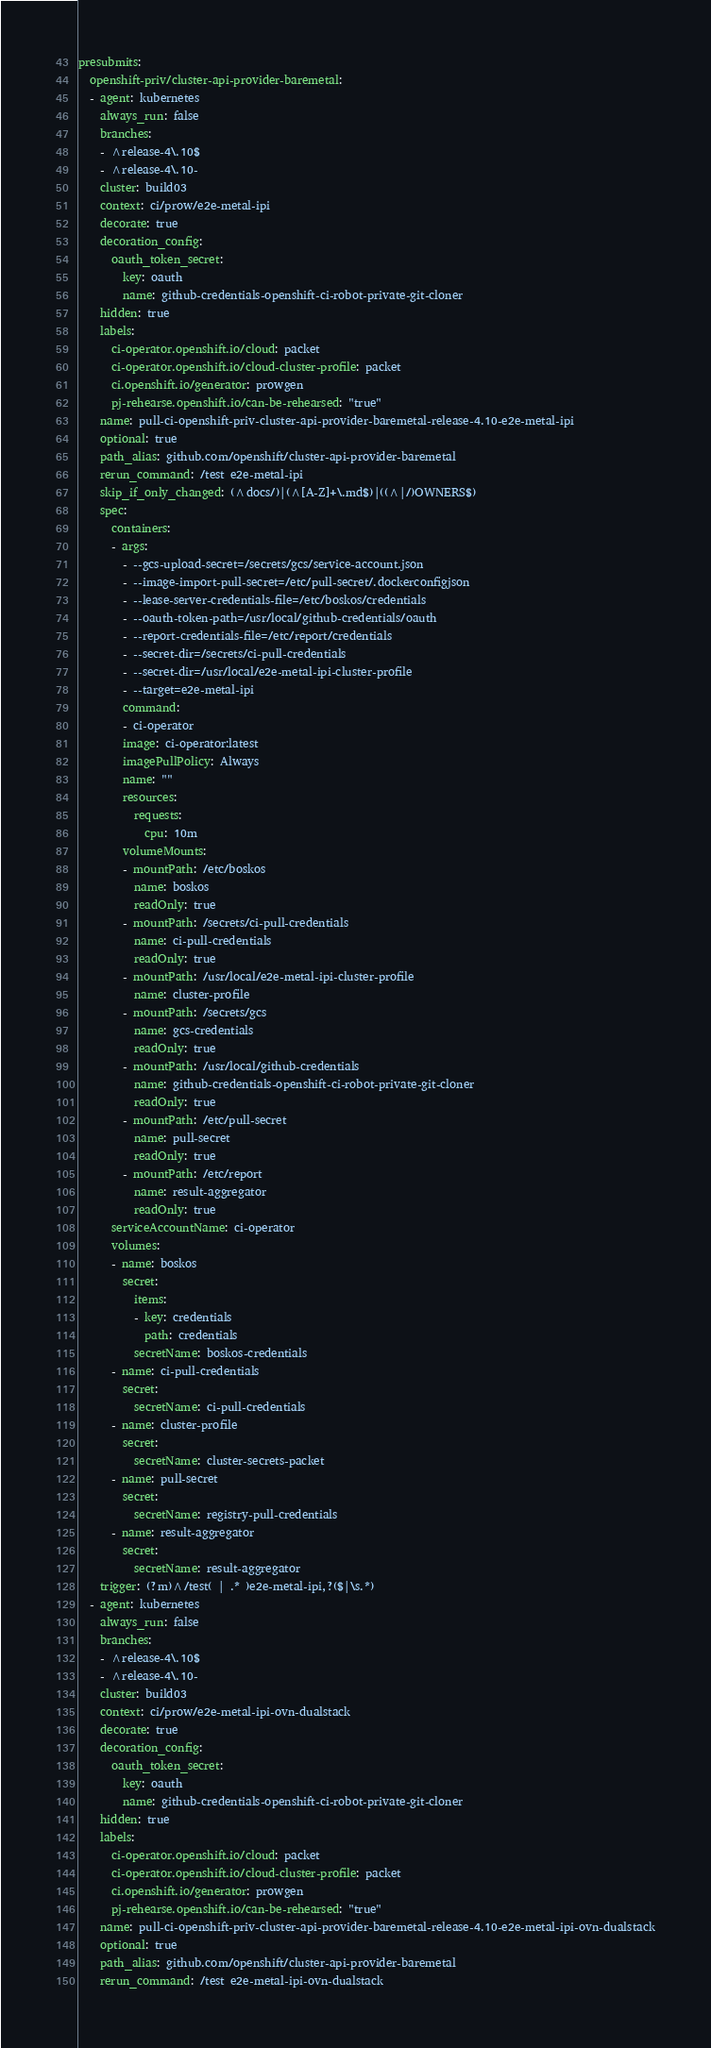<code> <loc_0><loc_0><loc_500><loc_500><_YAML_>presubmits:
  openshift-priv/cluster-api-provider-baremetal:
  - agent: kubernetes
    always_run: false
    branches:
    - ^release-4\.10$
    - ^release-4\.10-
    cluster: build03
    context: ci/prow/e2e-metal-ipi
    decorate: true
    decoration_config:
      oauth_token_secret:
        key: oauth
        name: github-credentials-openshift-ci-robot-private-git-cloner
    hidden: true
    labels:
      ci-operator.openshift.io/cloud: packet
      ci-operator.openshift.io/cloud-cluster-profile: packet
      ci.openshift.io/generator: prowgen
      pj-rehearse.openshift.io/can-be-rehearsed: "true"
    name: pull-ci-openshift-priv-cluster-api-provider-baremetal-release-4.10-e2e-metal-ipi
    optional: true
    path_alias: github.com/openshift/cluster-api-provider-baremetal
    rerun_command: /test e2e-metal-ipi
    skip_if_only_changed: (^docs/)|(^[A-Z]+\.md$)|((^|/)OWNERS$)
    spec:
      containers:
      - args:
        - --gcs-upload-secret=/secrets/gcs/service-account.json
        - --image-import-pull-secret=/etc/pull-secret/.dockerconfigjson
        - --lease-server-credentials-file=/etc/boskos/credentials
        - --oauth-token-path=/usr/local/github-credentials/oauth
        - --report-credentials-file=/etc/report/credentials
        - --secret-dir=/secrets/ci-pull-credentials
        - --secret-dir=/usr/local/e2e-metal-ipi-cluster-profile
        - --target=e2e-metal-ipi
        command:
        - ci-operator
        image: ci-operator:latest
        imagePullPolicy: Always
        name: ""
        resources:
          requests:
            cpu: 10m
        volumeMounts:
        - mountPath: /etc/boskos
          name: boskos
          readOnly: true
        - mountPath: /secrets/ci-pull-credentials
          name: ci-pull-credentials
          readOnly: true
        - mountPath: /usr/local/e2e-metal-ipi-cluster-profile
          name: cluster-profile
        - mountPath: /secrets/gcs
          name: gcs-credentials
          readOnly: true
        - mountPath: /usr/local/github-credentials
          name: github-credentials-openshift-ci-robot-private-git-cloner
          readOnly: true
        - mountPath: /etc/pull-secret
          name: pull-secret
          readOnly: true
        - mountPath: /etc/report
          name: result-aggregator
          readOnly: true
      serviceAccountName: ci-operator
      volumes:
      - name: boskos
        secret:
          items:
          - key: credentials
            path: credentials
          secretName: boskos-credentials
      - name: ci-pull-credentials
        secret:
          secretName: ci-pull-credentials
      - name: cluster-profile
        secret:
          secretName: cluster-secrets-packet
      - name: pull-secret
        secret:
          secretName: registry-pull-credentials
      - name: result-aggregator
        secret:
          secretName: result-aggregator
    trigger: (?m)^/test( | .* )e2e-metal-ipi,?($|\s.*)
  - agent: kubernetes
    always_run: false
    branches:
    - ^release-4\.10$
    - ^release-4\.10-
    cluster: build03
    context: ci/prow/e2e-metal-ipi-ovn-dualstack
    decorate: true
    decoration_config:
      oauth_token_secret:
        key: oauth
        name: github-credentials-openshift-ci-robot-private-git-cloner
    hidden: true
    labels:
      ci-operator.openshift.io/cloud: packet
      ci-operator.openshift.io/cloud-cluster-profile: packet
      ci.openshift.io/generator: prowgen
      pj-rehearse.openshift.io/can-be-rehearsed: "true"
    name: pull-ci-openshift-priv-cluster-api-provider-baremetal-release-4.10-e2e-metal-ipi-ovn-dualstack
    optional: true
    path_alias: github.com/openshift/cluster-api-provider-baremetal
    rerun_command: /test e2e-metal-ipi-ovn-dualstack</code> 